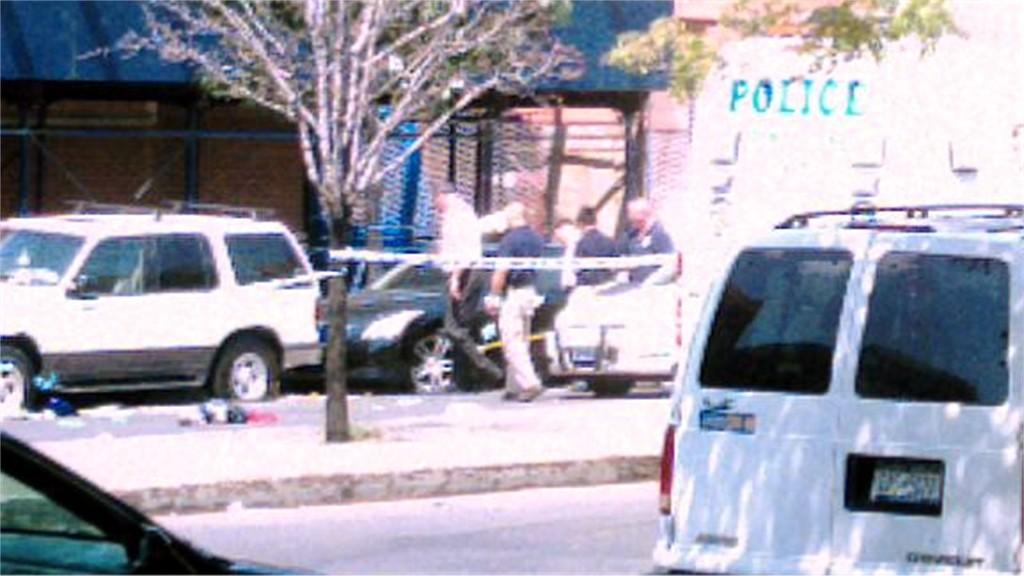Is there a police vehicle in the photo?
Provide a short and direct response. Yes. What brand is the white van in the foreground?
Offer a very short reply. Chevrolet. 